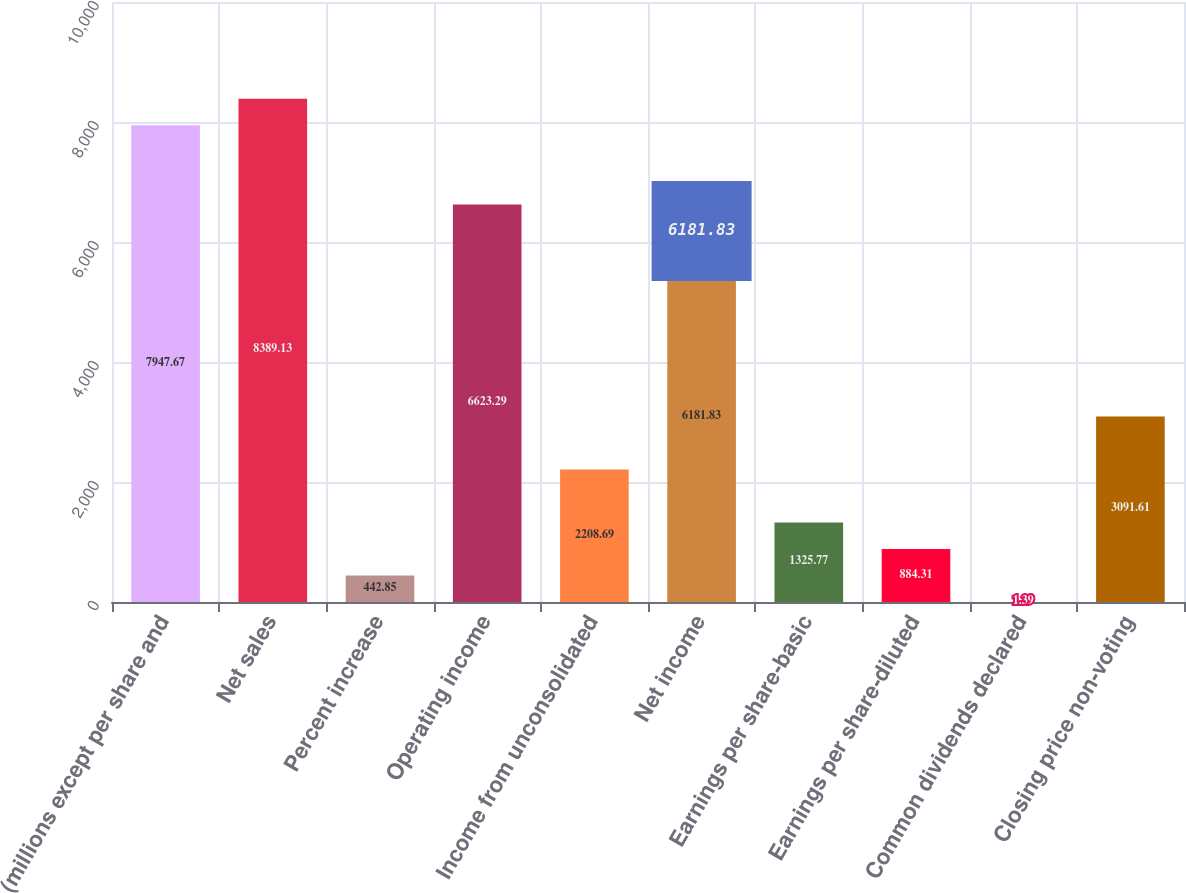Convert chart. <chart><loc_0><loc_0><loc_500><loc_500><bar_chart><fcel>(millions except per share and<fcel>Net sales<fcel>Percent increase<fcel>Operating income<fcel>Income from unconsolidated<fcel>Net income<fcel>Earnings per share-basic<fcel>Earnings per share-diluted<fcel>Common dividends declared<fcel>Closing price non-voting<nl><fcel>7947.67<fcel>8389.13<fcel>442.85<fcel>6623.29<fcel>2208.69<fcel>6181.83<fcel>1325.77<fcel>884.31<fcel>1.39<fcel>3091.61<nl></chart> 